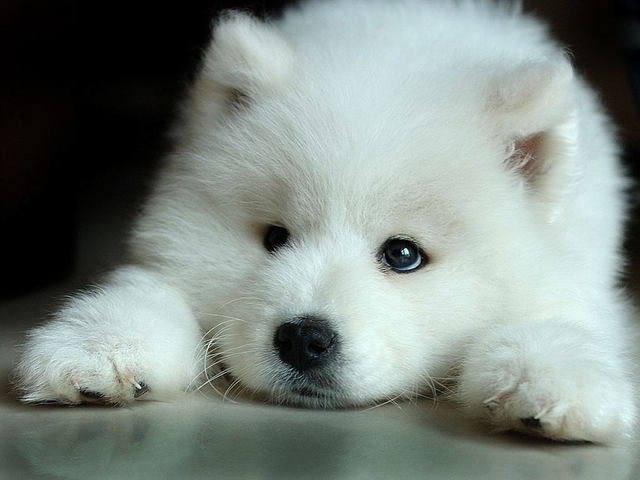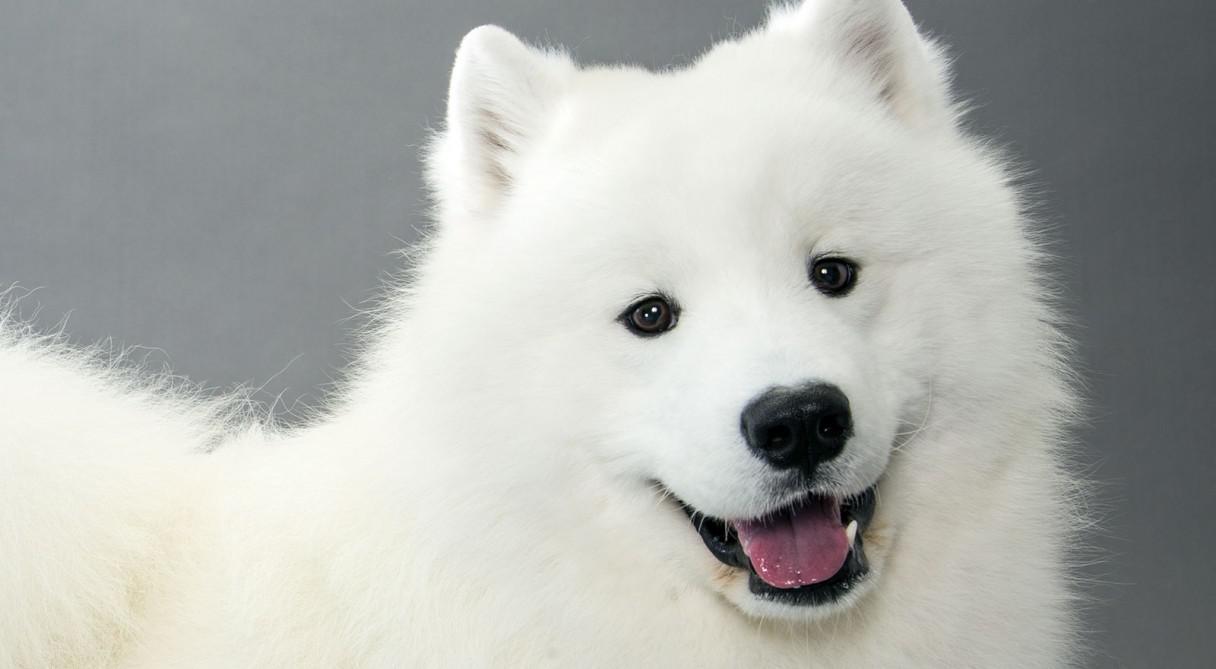The first image is the image on the left, the second image is the image on the right. Examine the images to the left and right. Is the description "There are two white dogs standing outside." accurate? Answer yes or no. No. 